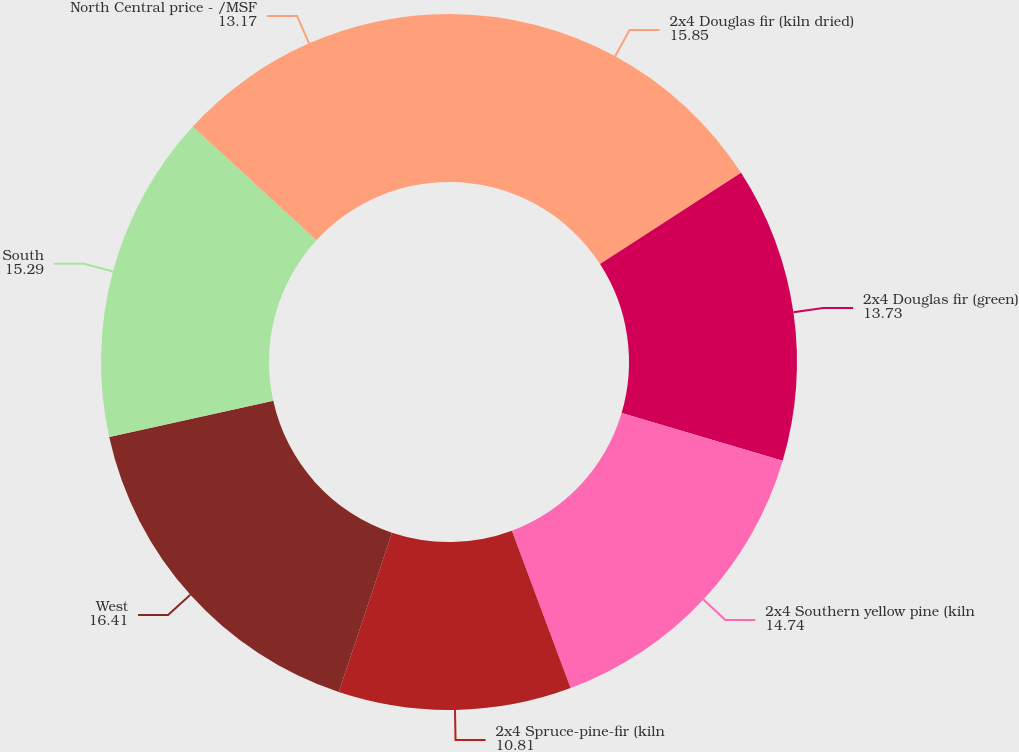<chart> <loc_0><loc_0><loc_500><loc_500><pie_chart><fcel>2x4 Douglas fir (kiln dried)<fcel>2x4 Douglas fir (green)<fcel>2x4 Southern yellow pine (kiln<fcel>2x4 Spruce-pine-fir (kiln<fcel>West<fcel>South<fcel>North Central price - /MSF<nl><fcel>15.85%<fcel>13.73%<fcel>14.74%<fcel>10.81%<fcel>16.41%<fcel>15.29%<fcel>13.17%<nl></chart> 